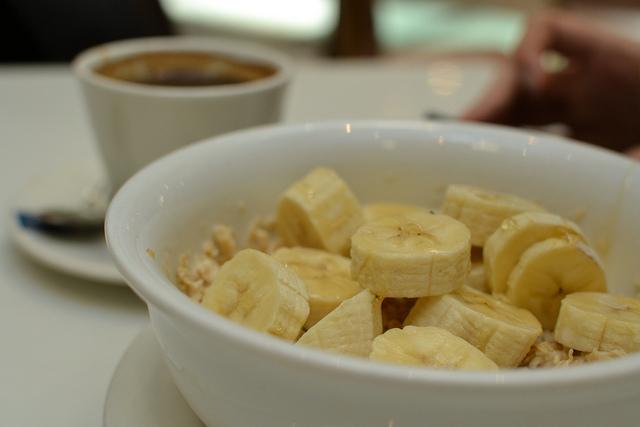What types of fruit are in the bowl?
Keep it brief. Banana. What kind of container is the food in?
Answer briefly. Bowl. What is in the  bowl?
Answer briefly. Bananas. Is this a vegetable stew?
Concise answer only. No. Is this food cooked?
Concise answer only. No. Is the tablecloth stained?
Short answer required. No. What is this?
Be succinct. Bananas. What kind of fruit is in the bowl?
Be succinct. Banana. What region does this fruit come from?
Give a very brief answer. South america. What type of fruit is in the picture?
Give a very brief answer. Banana. What food is this?
Short answer required. Banana. What is the liquid with the bananas?
Answer briefly. Coffee. What is the drink?
Give a very brief answer. Coffee. Are there nuts in this dish?
Quick response, please. No. Are there veggies?
Concise answer only. No. What color is the bowl?
Write a very short answer. White. Is there more than one variety of fruit visible in this photo?
Keep it brief. No. Where is the banana?
Answer briefly. In bowl. What kinds of fruit are in this picture?
Quick response, please. Banana. Could you eat all these bananas by yourself?
Concise answer only. Yes. How many cups are there?
Be succinct. 1. Does this look good?
Concise answer only. Yes. How are the bananas prepared?
Be succinct. Sliced. What kind of drink is that?
Answer briefly. Coffee. Is this food good for someone on diet?
Give a very brief answer. Yes. What makes this meal a healthy choice?
Write a very short answer. Fruit. What kinds of fruit are in this photo?
Quick response, please. Banana. 